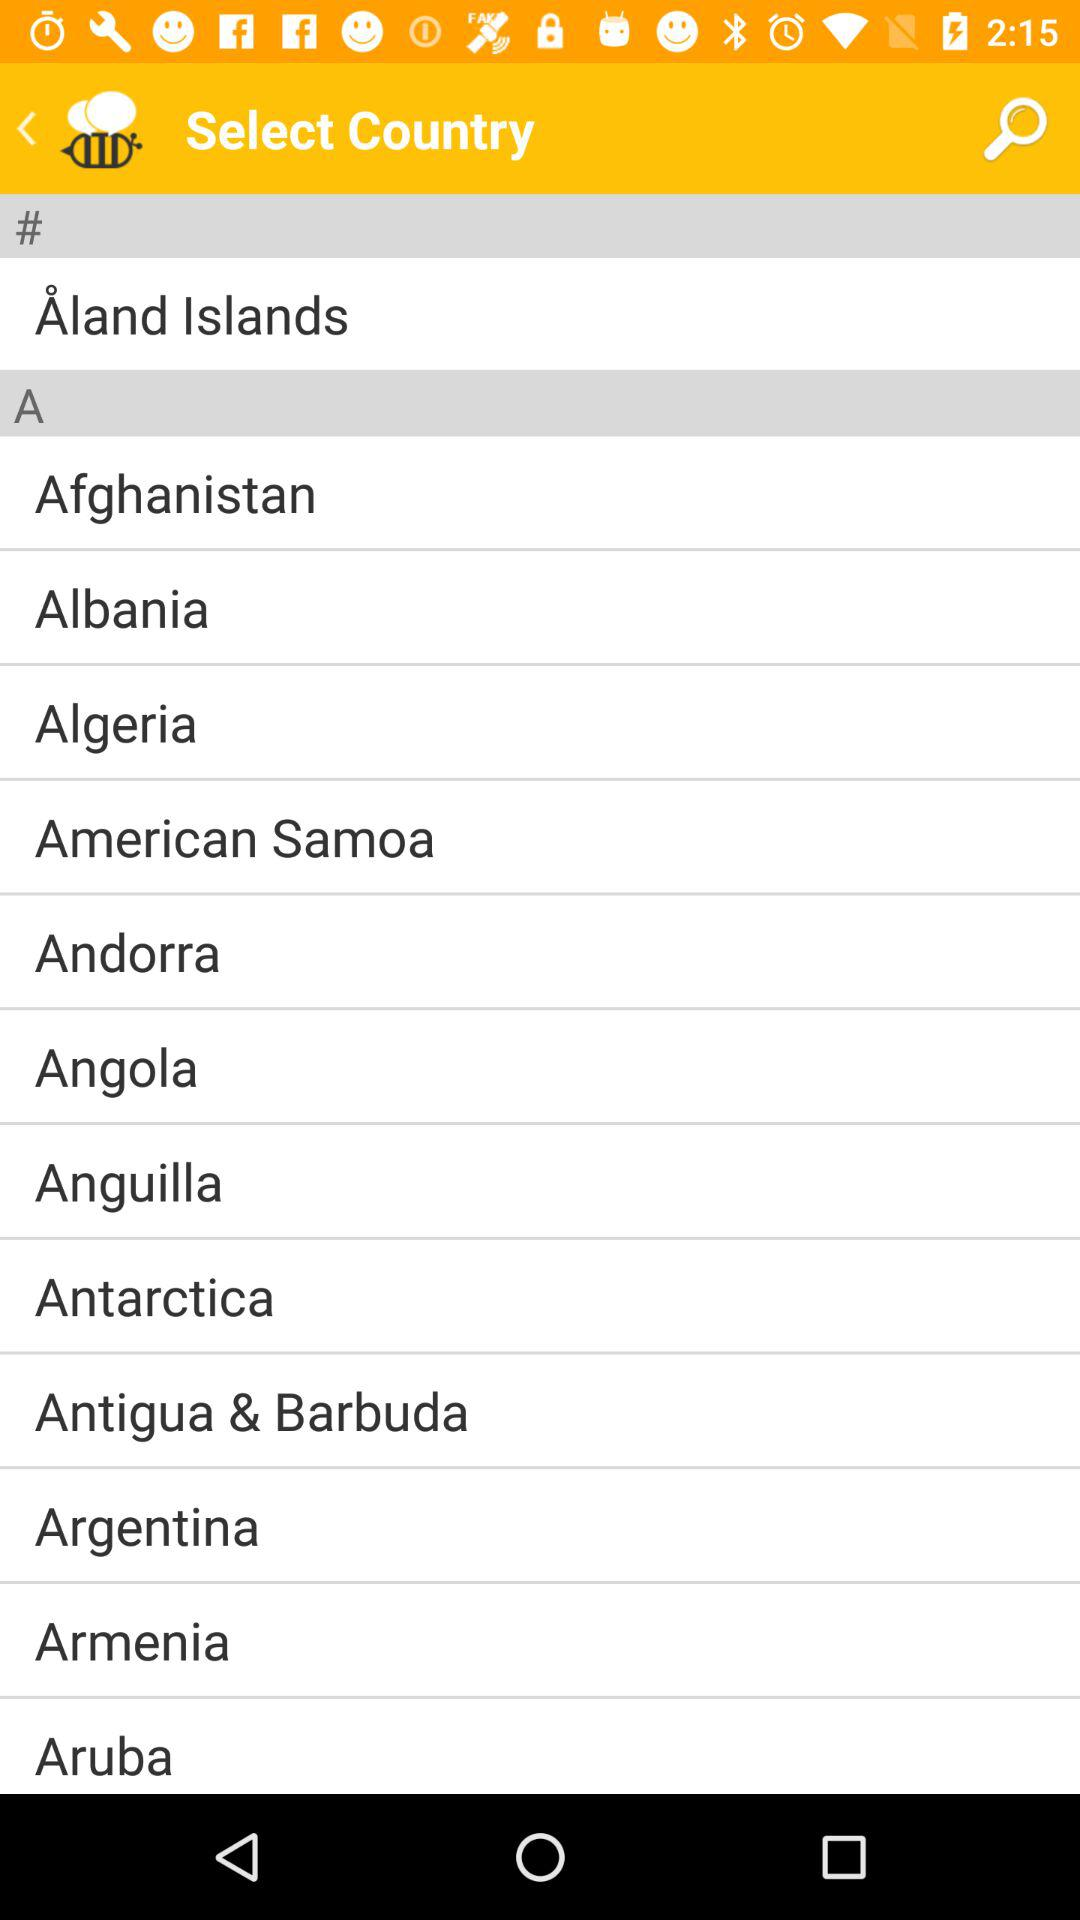What's the opted Country?
When the provided information is insufficient, respond with <no answer>. <no answer> 